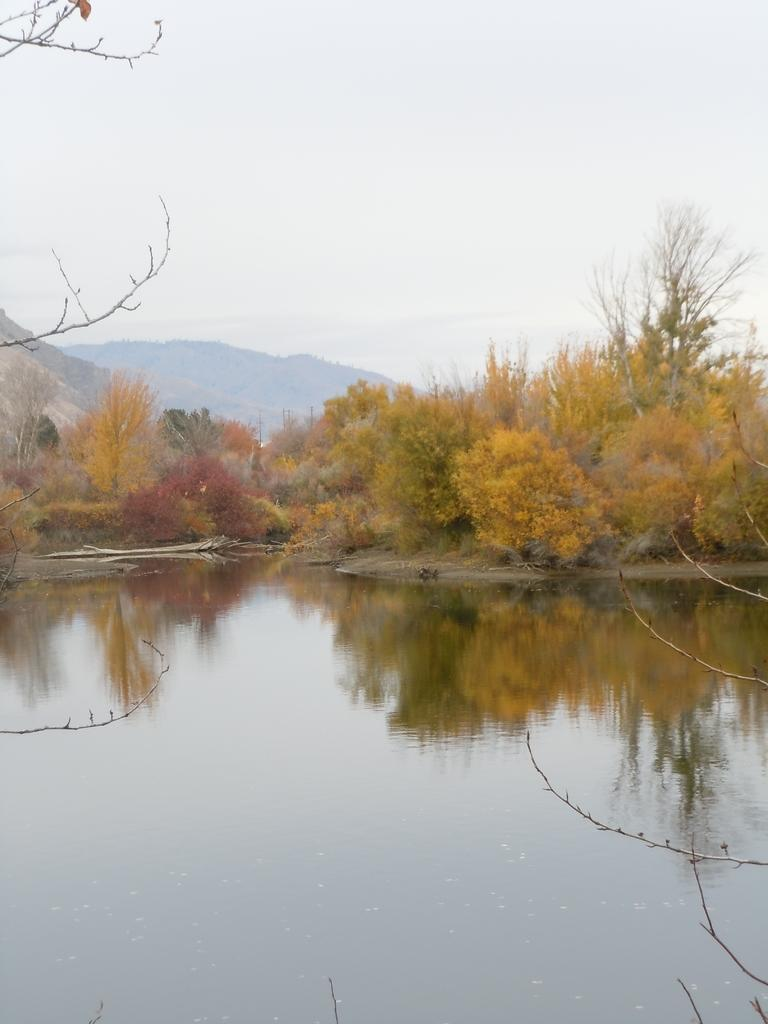What type of natural feature is the main subject of the image? There is a lake in the image. What other natural elements can be seen in the image? There are trees visible in the image. What can be seen in the distance in the image? There are hills visible in the background of the image. What is visible above the hills in the image? The sky is visible in the background of the image. Where is the cemetery located in the image? There is no cemetery present in the image. What type of island can be seen in the middle of the lake in the image? There is no island present in the image; it is a lake surrounded by trees and hills. 